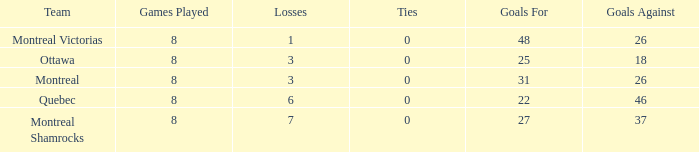How many losses did the team with 22 goals for andmore than 8 games played have? 0.0. 